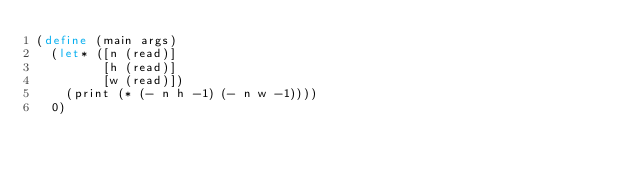Convert code to text. <code><loc_0><loc_0><loc_500><loc_500><_Scheme_>(define (main args)
  (let* ([n (read)]
         [h (read)]
         [w (read)])
    (print (* (- n h -1) (- n w -1))))
  0)
</code> 